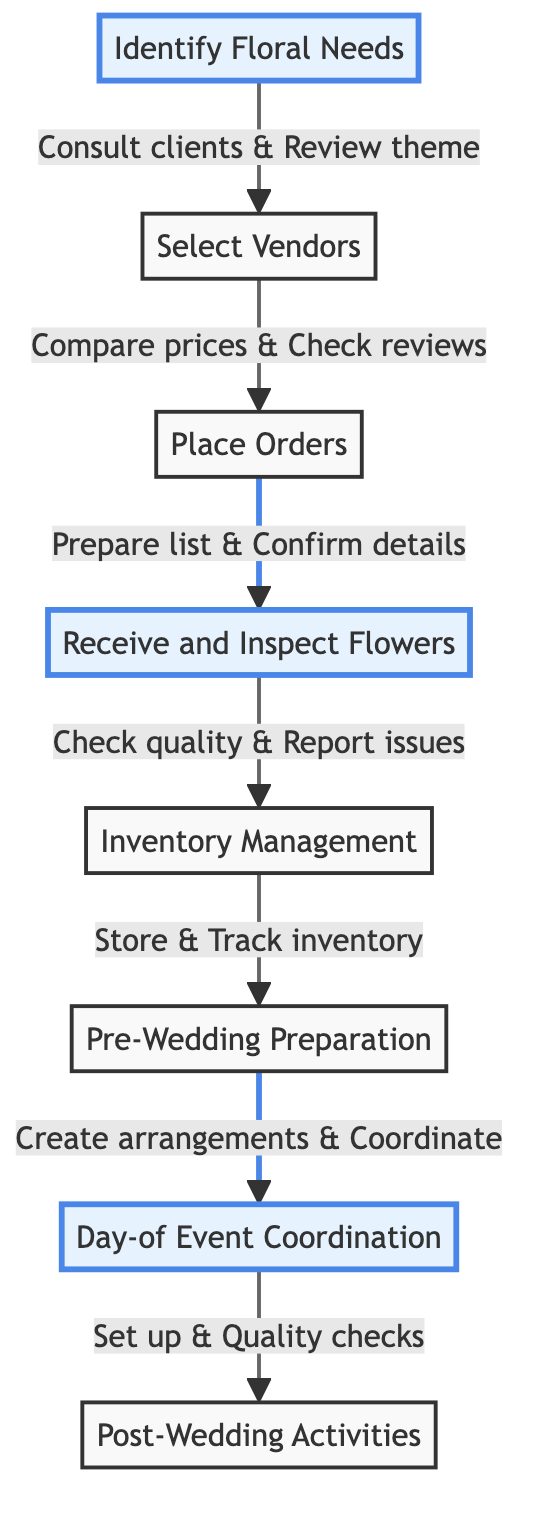What is the first step in the workflow? The first step in the workflow is "Identify Floral Needs," which is positioned at the beginning of the flow chart.
Answer: Identify Floral Needs How many steps are in the workflow? By counting each node in the flow chart, there are a total of eight steps including the beginning and end nodes.
Answer: Eight What is the step following "Receive and Inspect Flowers"? In the flow of the diagram, the step that follows "Receive and Inspect Flowers" is "Inventory Management."
Answer: Inventory Management Which step involves preparation and arrangement of flowers? The step that involves the preparation and arrangement of flowers is labeled as "Pre-Wedding Preparation."
Answer: Pre-Wedding Preparation What is one task listed under "Select Vendors"? One task listed under "Select Vendors" is "Contact multiple vendors," as per the details of that step.
Answer: Contact multiple vendors What connects "Place Orders" and "Receive and Inspect Flowers"? The connection between "Place Orders" and "Receive and Inspect Flowers" is through the action "Ensure to meet the required dates and quantities," which links these two steps together.
Answer: Ensure to meet the required dates and quantities How many stages involve direct coordination with clients or vendors? There are four stages that involve direct coordination with clients or vendors: "Identify Floral Needs," "Select Vendors," "Pre-Wedding Preparation," and "Day-of Event Coordination."
Answer: Four Which step provides final quality checks? The step that provides final quality checks is "Day-of Event Coordination," which is where the setups are verified for quality.
Answer: Day-of Event Coordination What happens during "Post-Wedding Activities"? During "Post-Wedding Activities," processes such as collecting used arrangements and coordinating flower donations are carried out as specified in the flow chart.
Answer: Collect used arrangements and coordinate flower donations 